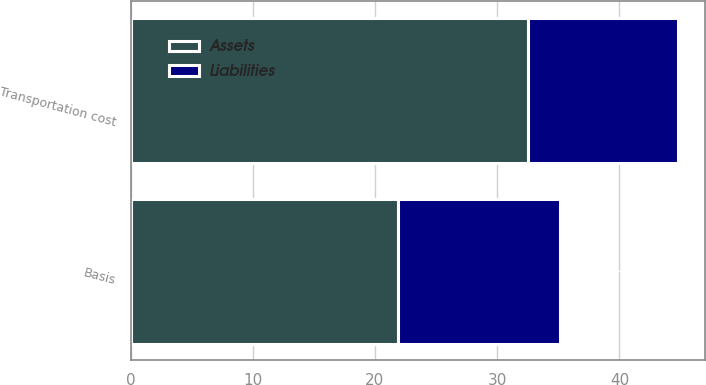<chart> <loc_0><loc_0><loc_500><loc_500><stacked_bar_chart><ecel><fcel>Basis<fcel>Transportation cost<nl><fcel>Assets<fcel>21.9<fcel>32.5<nl><fcel>Liabilities<fcel>13.2<fcel>12.3<nl></chart> 